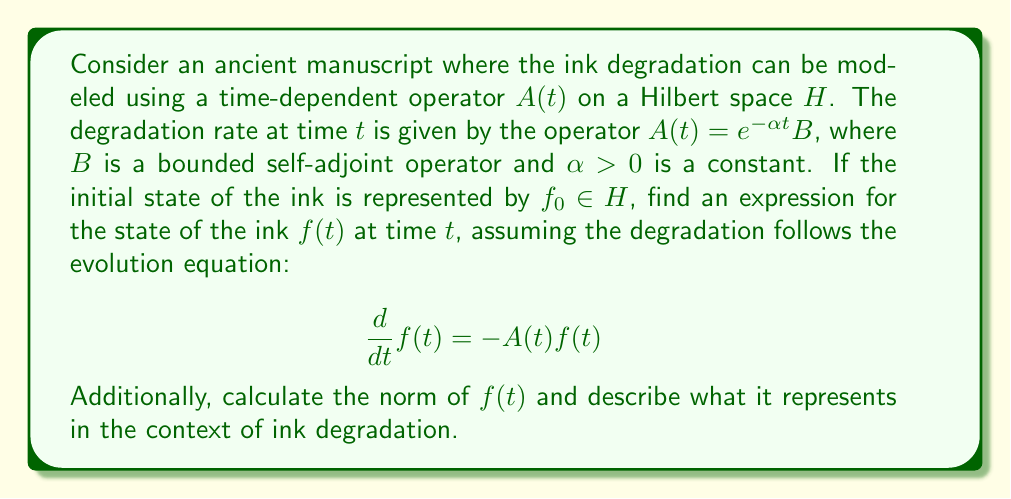Give your solution to this math problem. To solve this problem, we'll follow these steps:

1) First, we need to solve the evolution equation:
   $$\frac{d}{dt}f(t) = -A(t)f(t) = -e^{-\alpha t}Bf(t)$$

2) This is a linear differential equation. The solution has the form:
   $$f(t) = e^{-\int_0^t A(s)ds}f_0$$

3) Let's calculate the integral in the exponent:
   $$\int_0^t A(s)ds = \int_0^t e^{-\alpha s}Bds = B\int_0^t e^{-\alpha s}ds = \frac{B}{\alpha}(1-e^{-\alpha t})$$

4) Therefore, the solution is:
   $$f(t) = e^{-\frac{B}{\alpha}(1-e^{-\alpha t})}f_0$$

5) Now, let's calculate the norm of $f(t)$:
   $$\|f(t)\| = \|e^{-\frac{B}{\alpha}(1-e^{-\alpha t})}f_0\|$$

6) Since $B$ is self-adjoint, by the spectral theorem, we can write:
   $$\|f(t)\| = \|e^{-\frac{1}{\alpha}(1-e^{-\alpha t})\lambda}f_0\|$$
   where $\lambda$ represents the eigenvalues of $B$.

7) The norm will be bounded by:
   $$e^{-\frac{\|\lambda\|}{\alpha}(1-e^{-\alpha t})}\|f_0\| \leq \|f(t)\| \leq \|f_0\|$$

In the context of ink degradation, $\|f(t)\|$ represents the "intensity" or "strength" of the ink at time $t$. As $t$ increases, $\|f(t)\|$ decreases, indicating that the ink is fading over time. The rate of this fading is controlled by the parameters $\alpha$ and the eigenvalues of $B$.
Answer: The state of the ink at time $t$ is given by:
$$f(t) = e^{-\frac{B}{\alpha}(1-e^{-\alpha t})}f_0$$

The norm of $f(t)$ is bounded by:
$$e^{-\frac{\|\lambda\|}{\alpha}(1-e^{-\alpha t})}\|f_0\| \leq \|f(t)\| \leq \|f_0\|$$

This norm represents the intensity of the ink, which decreases over time, modeling the fading process. 